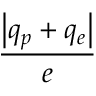<formula> <loc_0><loc_0><loc_500><loc_500>\frac { \left | q _ { p } + q _ { e } \right | } { e }</formula> 